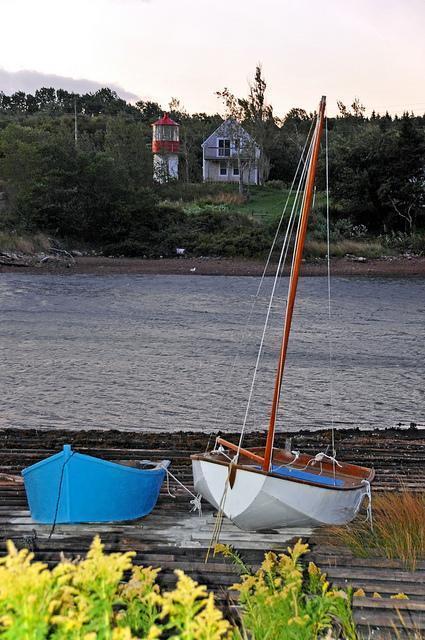How many boats are in the photo?
Give a very brief answer. 2. 